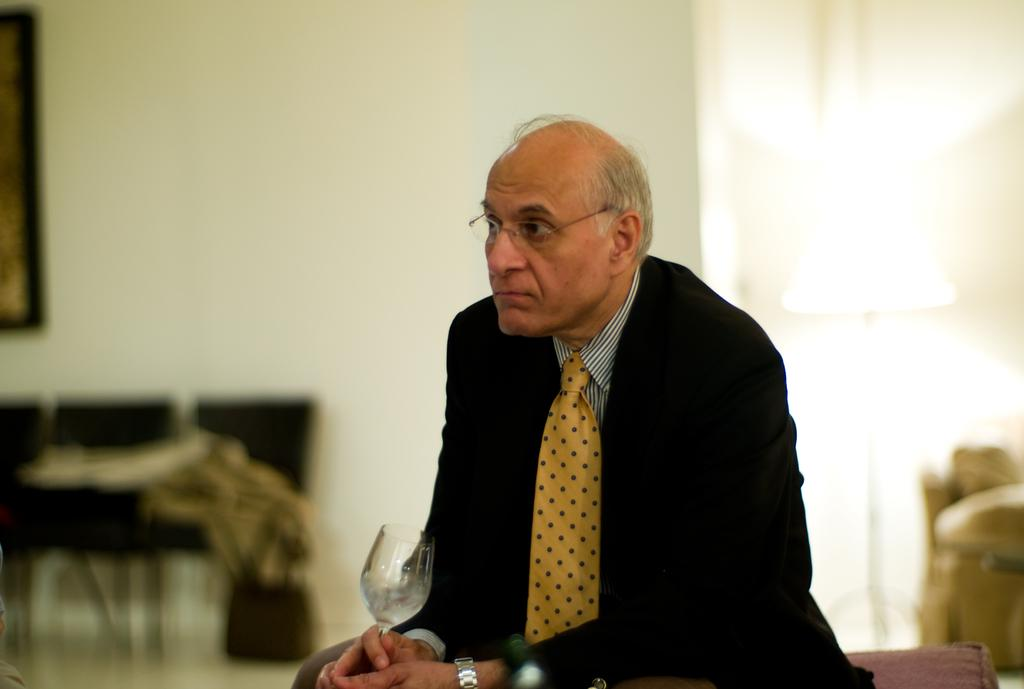Who is present in the image? There is a man in the image. What is the man doing in the image? The man is sitting. What is the man holding in his hand? The man is holding a wine glass in his hand. Can you describe the background of the image? The background of the image is blurry. What type of doll is the man's daughter playing with in the image? There is no mention of a daughter or a doll in the image; it only features a man sitting and holding a wine glass. 